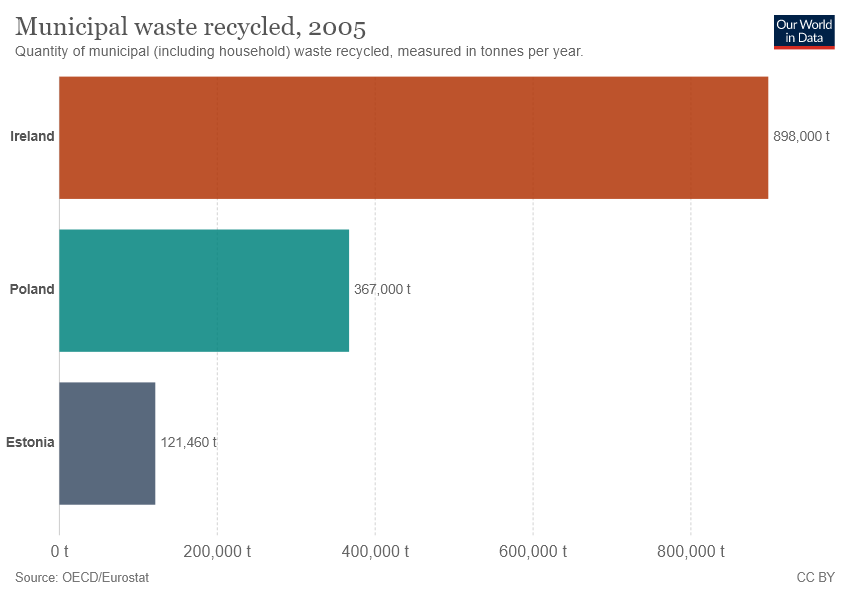Give some essential details in this illustration. The highest value of the bar variable is 898000. Ireland is the bar that has the value of 898000. 